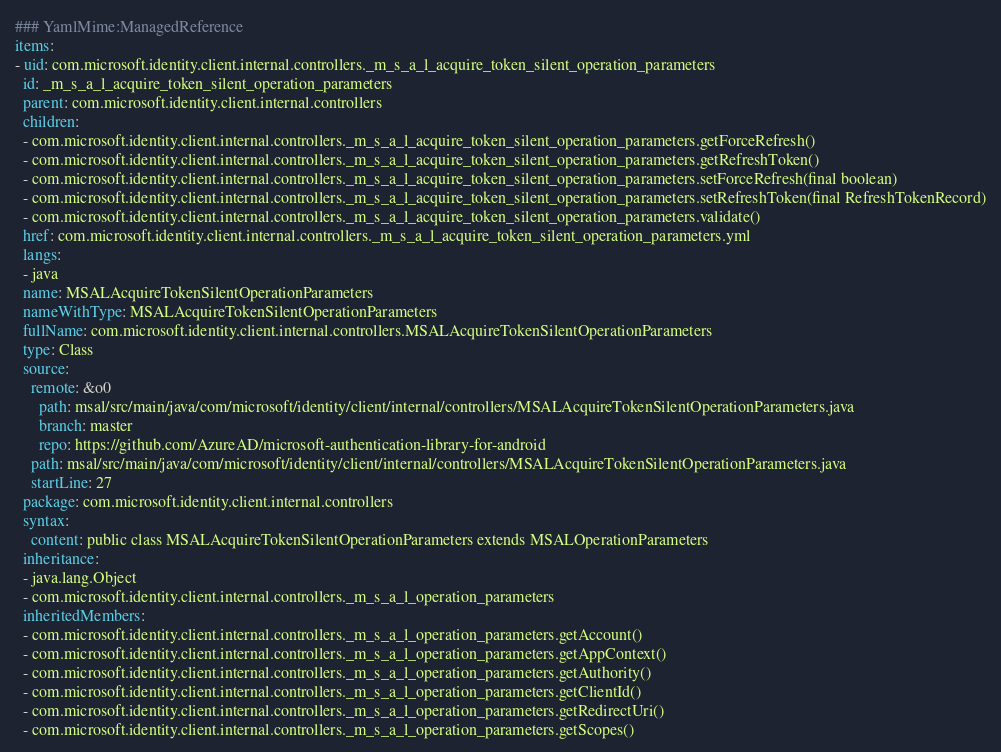<code> <loc_0><loc_0><loc_500><loc_500><_YAML_>### YamlMime:ManagedReference
items:
- uid: com.microsoft.identity.client.internal.controllers._m_s_a_l_acquire_token_silent_operation_parameters
  id: _m_s_a_l_acquire_token_silent_operation_parameters
  parent: com.microsoft.identity.client.internal.controllers
  children:
  - com.microsoft.identity.client.internal.controllers._m_s_a_l_acquire_token_silent_operation_parameters.getForceRefresh()
  - com.microsoft.identity.client.internal.controllers._m_s_a_l_acquire_token_silent_operation_parameters.getRefreshToken()
  - com.microsoft.identity.client.internal.controllers._m_s_a_l_acquire_token_silent_operation_parameters.setForceRefresh(final boolean)
  - com.microsoft.identity.client.internal.controllers._m_s_a_l_acquire_token_silent_operation_parameters.setRefreshToken(final RefreshTokenRecord)
  - com.microsoft.identity.client.internal.controllers._m_s_a_l_acquire_token_silent_operation_parameters.validate()
  href: com.microsoft.identity.client.internal.controllers._m_s_a_l_acquire_token_silent_operation_parameters.yml
  langs:
  - java
  name: MSALAcquireTokenSilentOperationParameters
  nameWithType: MSALAcquireTokenSilentOperationParameters
  fullName: com.microsoft.identity.client.internal.controllers.MSALAcquireTokenSilentOperationParameters
  type: Class
  source:
    remote: &o0
      path: msal/src/main/java/com/microsoft/identity/client/internal/controllers/MSALAcquireTokenSilentOperationParameters.java
      branch: master
      repo: https://github.com/AzureAD/microsoft-authentication-library-for-android
    path: msal/src/main/java/com/microsoft/identity/client/internal/controllers/MSALAcquireTokenSilentOperationParameters.java
    startLine: 27
  package: com.microsoft.identity.client.internal.controllers
  syntax:
    content: public class MSALAcquireTokenSilentOperationParameters extends MSALOperationParameters
  inheritance:
  - java.lang.Object
  - com.microsoft.identity.client.internal.controllers._m_s_a_l_operation_parameters
  inheritedMembers:
  - com.microsoft.identity.client.internal.controllers._m_s_a_l_operation_parameters.getAccount()
  - com.microsoft.identity.client.internal.controllers._m_s_a_l_operation_parameters.getAppContext()
  - com.microsoft.identity.client.internal.controllers._m_s_a_l_operation_parameters.getAuthority()
  - com.microsoft.identity.client.internal.controllers._m_s_a_l_operation_parameters.getClientId()
  - com.microsoft.identity.client.internal.controllers._m_s_a_l_operation_parameters.getRedirectUri()
  - com.microsoft.identity.client.internal.controllers._m_s_a_l_operation_parameters.getScopes()</code> 